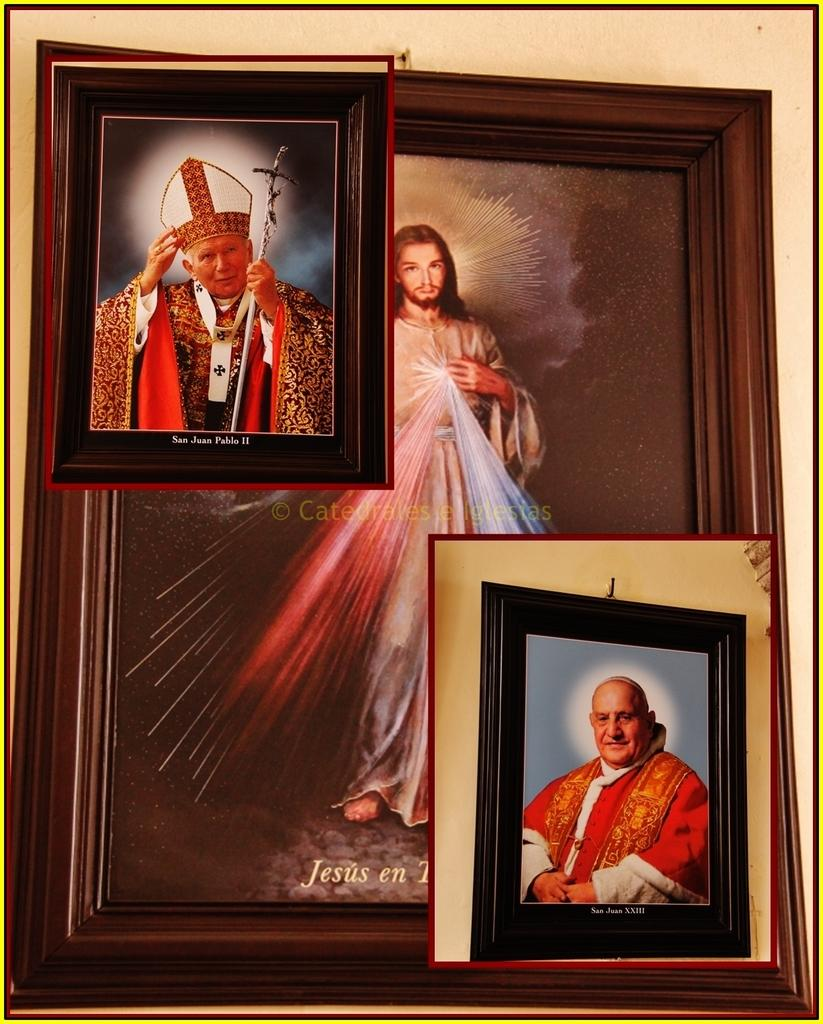<image>
Write a terse but informative summary of the picture. pictures in frames with one of them labeled 'san juan pablo II' at the bottom 